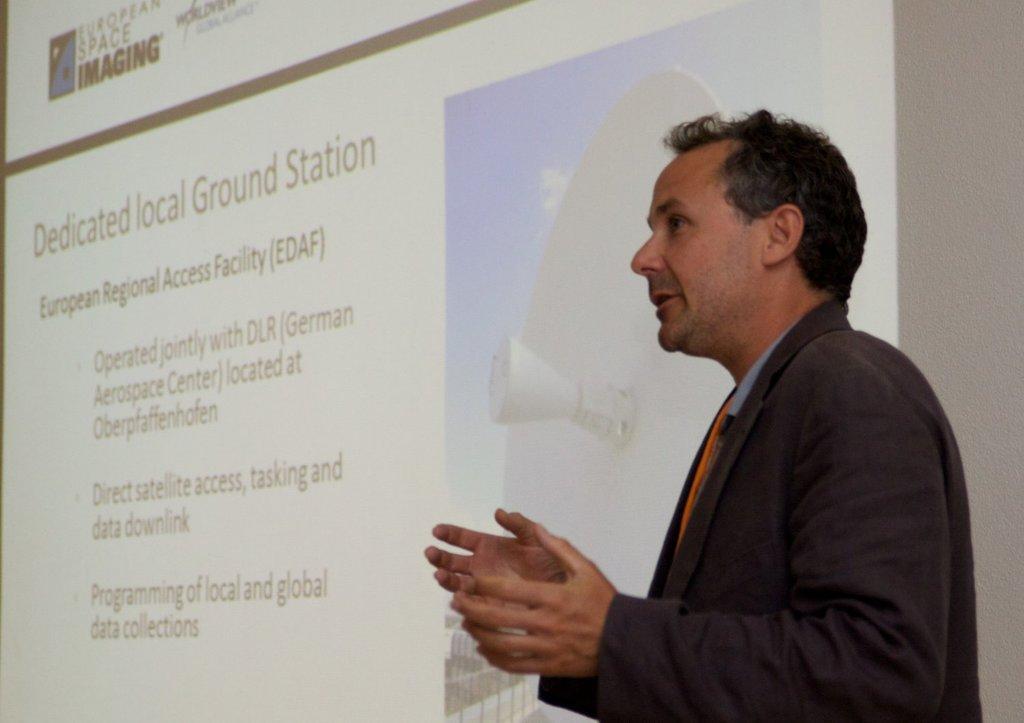In one or two sentences, can you explain what this image depicts? In this picture there is a man wearing black color standing and explaining something. Behind there is a white color projector screen. 